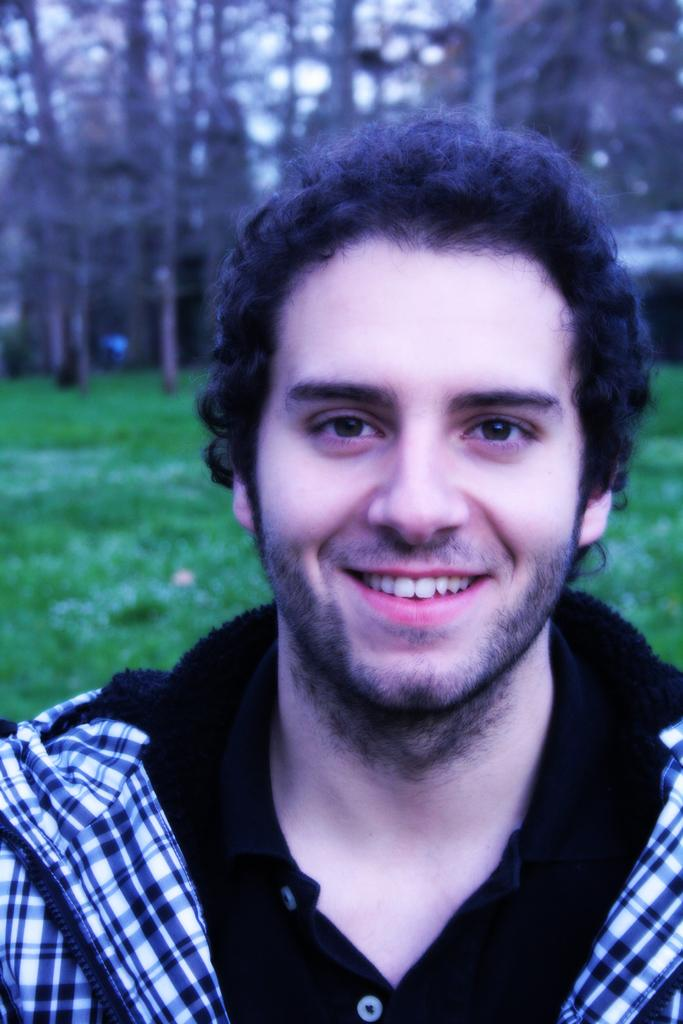Who is present in the image? There is a man in the image. What is the man's facial expression? The man is smiling. What type of natural environment is visible in the background of the image? There is grass, trees, and the sky visible in the background of the image. What type of ornament is hanging from the tree in the image? There is no ornament hanging from the tree in the image; only grass, trees, and the sky are visible in the background. 